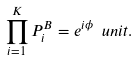Convert formula to latex. <formula><loc_0><loc_0><loc_500><loc_500>\prod _ { i = 1 } ^ { K } P ^ { B } _ { i } = e ^ { i \phi } \ u n i t .</formula> 